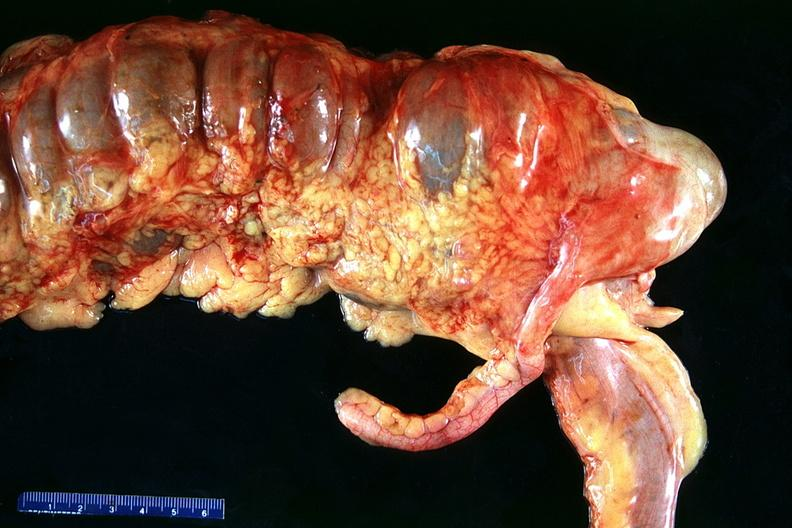where does this belong to?
Answer the question using a single word or phrase. Gastrointestinal system 